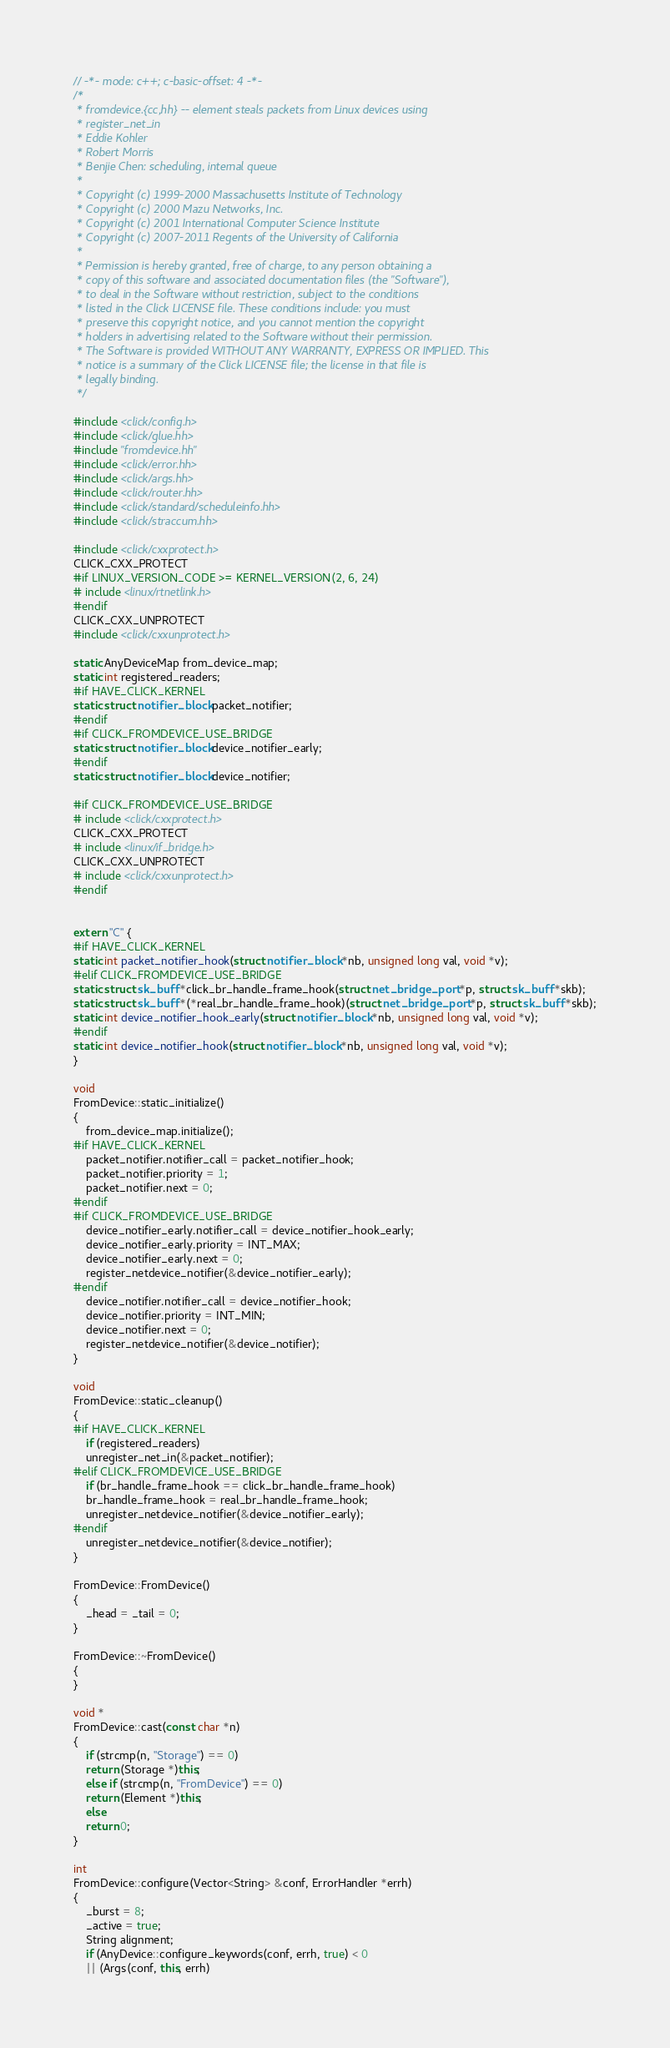Convert code to text. <code><loc_0><loc_0><loc_500><loc_500><_C++_>// -*- mode: c++; c-basic-offset: 4 -*-
/*
 * fromdevice.{cc,hh} -- element steals packets from Linux devices using
 * register_net_in
 * Eddie Kohler
 * Robert Morris
 * Benjie Chen: scheduling, internal queue
 *
 * Copyright (c) 1999-2000 Massachusetts Institute of Technology
 * Copyright (c) 2000 Mazu Networks, Inc.
 * Copyright (c) 2001 International Computer Science Institute
 * Copyright (c) 2007-2011 Regents of the University of California
 *
 * Permission is hereby granted, free of charge, to any person obtaining a
 * copy of this software and associated documentation files (the "Software"),
 * to deal in the Software without restriction, subject to the conditions
 * listed in the Click LICENSE file. These conditions include: you must
 * preserve this copyright notice, and you cannot mention the copyright
 * holders in advertising related to the Software without their permission.
 * The Software is provided WITHOUT ANY WARRANTY, EXPRESS OR IMPLIED. This
 * notice is a summary of the Click LICENSE file; the license in that file is
 * legally binding.
 */

#include <click/config.h>
#include <click/glue.hh>
#include "fromdevice.hh"
#include <click/error.hh>
#include <click/args.hh>
#include <click/router.hh>
#include <click/standard/scheduleinfo.hh>
#include <click/straccum.hh>

#include <click/cxxprotect.h>
CLICK_CXX_PROTECT
#if LINUX_VERSION_CODE >= KERNEL_VERSION(2, 6, 24)
# include <linux/rtnetlink.h>
#endif
CLICK_CXX_UNPROTECT
#include <click/cxxunprotect.h>

static AnyDeviceMap from_device_map;
static int registered_readers;
#if HAVE_CLICK_KERNEL
static struct notifier_block packet_notifier;
#endif
#if CLICK_FROMDEVICE_USE_BRIDGE
static struct notifier_block device_notifier_early;
#endif
static struct notifier_block device_notifier;

#if CLICK_FROMDEVICE_USE_BRIDGE
# include <click/cxxprotect.h>
CLICK_CXX_PROTECT
# include <linux/if_bridge.h>
CLICK_CXX_UNPROTECT
# include <click/cxxunprotect.h>
#endif


extern "C" {
#if HAVE_CLICK_KERNEL
static int packet_notifier_hook(struct notifier_block *nb, unsigned long val, void *v);
#elif CLICK_FROMDEVICE_USE_BRIDGE
static struct sk_buff *click_br_handle_frame_hook(struct net_bridge_port *p, struct sk_buff *skb);
static struct sk_buff *(*real_br_handle_frame_hook)(struct net_bridge_port *p, struct sk_buff *skb);
static int device_notifier_hook_early(struct notifier_block *nb, unsigned long val, void *v);
#endif
static int device_notifier_hook(struct notifier_block *nb, unsigned long val, void *v);
}

void
FromDevice::static_initialize()
{
    from_device_map.initialize();
#if HAVE_CLICK_KERNEL
    packet_notifier.notifier_call = packet_notifier_hook;
    packet_notifier.priority = 1;
    packet_notifier.next = 0;
#endif
#if CLICK_FROMDEVICE_USE_BRIDGE
    device_notifier_early.notifier_call = device_notifier_hook_early;
    device_notifier_early.priority = INT_MAX;
    device_notifier_early.next = 0;
    register_netdevice_notifier(&device_notifier_early);
#endif
    device_notifier.notifier_call = device_notifier_hook;
    device_notifier.priority = INT_MIN;
    device_notifier.next = 0;
    register_netdevice_notifier(&device_notifier);
}

void
FromDevice::static_cleanup()
{
#if HAVE_CLICK_KERNEL
    if (registered_readers)
	unregister_net_in(&packet_notifier);
#elif CLICK_FROMDEVICE_USE_BRIDGE
    if (br_handle_frame_hook == click_br_handle_frame_hook)
	br_handle_frame_hook = real_br_handle_frame_hook;
    unregister_netdevice_notifier(&device_notifier_early);
#endif
    unregister_netdevice_notifier(&device_notifier);
}

FromDevice::FromDevice()
{
    _head = _tail = 0;
}

FromDevice::~FromDevice()
{
}

void *
FromDevice::cast(const char *n)
{
    if (strcmp(n, "Storage") == 0)
	return (Storage *)this;
    else if (strcmp(n, "FromDevice") == 0)
	return (Element *)this;
    else
	return 0;
}

int
FromDevice::configure(Vector<String> &conf, ErrorHandler *errh)
{
    _burst = 8;
    _active = true;
    String alignment;
    if (AnyDevice::configure_keywords(conf, errh, true) < 0
	|| (Args(conf, this, errh)</code> 